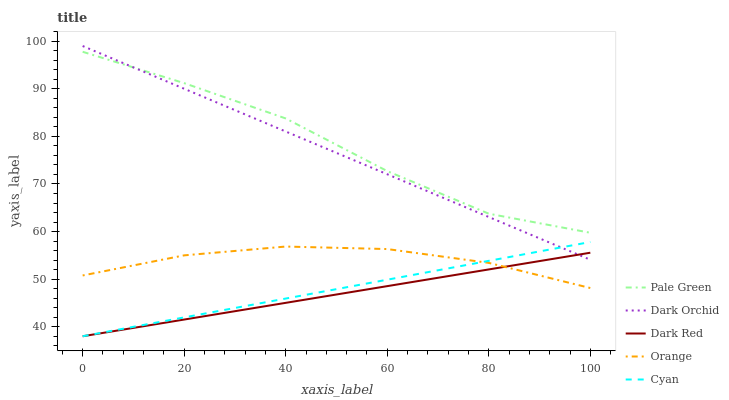Does Dark Red have the minimum area under the curve?
Answer yes or no. Yes. Does Pale Green have the maximum area under the curve?
Answer yes or no. Yes. Does Pale Green have the minimum area under the curve?
Answer yes or no. No. Does Dark Red have the maximum area under the curve?
Answer yes or no. No. Is Dark Orchid the smoothest?
Answer yes or no. Yes. Is Pale Green the roughest?
Answer yes or no. Yes. Is Dark Red the smoothest?
Answer yes or no. No. Is Dark Red the roughest?
Answer yes or no. No. Does Pale Green have the lowest value?
Answer yes or no. No. Does Dark Orchid have the highest value?
Answer yes or no. Yes. Does Pale Green have the highest value?
Answer yes or no. No. Is Orange less than Dark Orchid?
Answer yes or no. Yes. Is Dark Orchid greater than Orange?
Answer yes or no. Yes. Does Cyan intersect Orange?
Answer yes or no. Yes. Is Cyan less than Orange?
Answer yes or no. No. Is Cyan greater than Orange?
Answer yes or no. No. Does Orange intersect Dark Orchid?
Answer yes or no. No. 